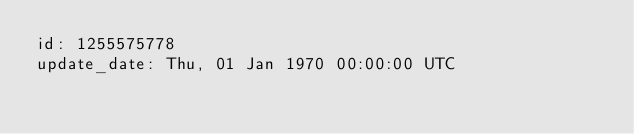Convert code to text. <code><loc_0><loc_0><loc_500><loc_500><_YAML_>id: 1255575778
update_date: Thu, 01 Jan 1970 00:00:00 UTC
</code> 